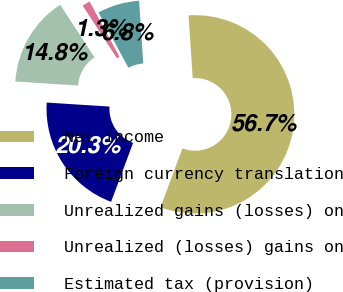Convert chart to OTSL. <chart><loc_0><loc_0><loc_500><loc_500><pie_chart><fcel>Net income<fcel>Foreign currency translation<fcel>Unrealized gains (losses) on<fcel>Unrealized (losses) gains on<fcel>Estimated tax (provision)<nl><fcel>56.73%<fcel>20.34%<fcel>14.8%<fcel>1.29%<fcel>6.84%<nl></chart> 